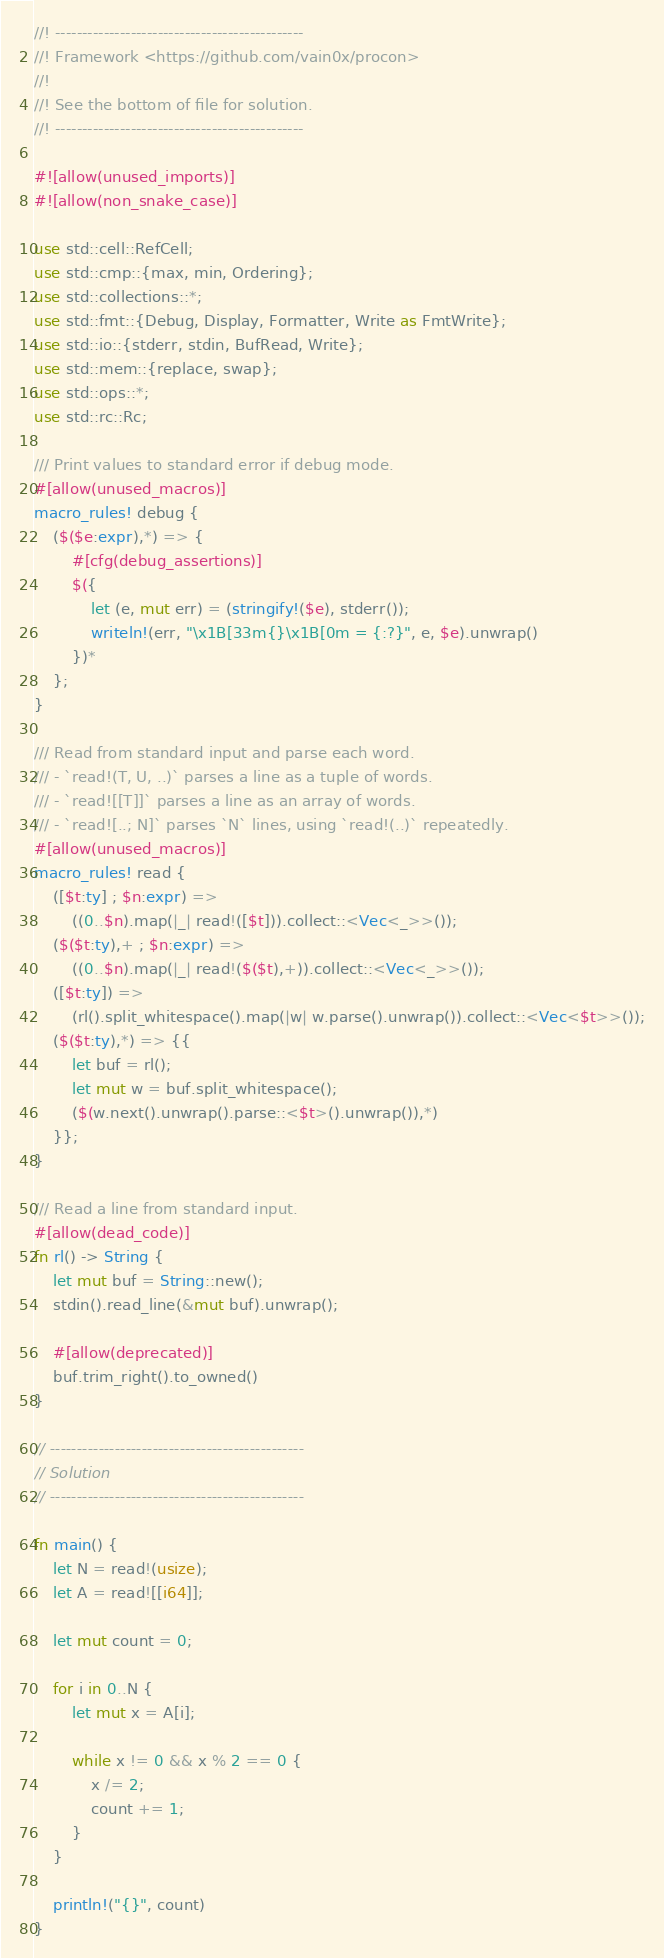<code> <loc_0><loc_0><loc_500><loc_500><_Rust_>//! ----------------------------------------------
//! Framework <https://github.com/vain0x/procon>
//!
//! See the bottom of file for solution.
//! ----------------------------------------------

#![allow(unused_imports)]
#![allow(non_snake_case)]

use std::cell::RefCell;
use std::cmp::{max, min, Ordering};
use std::collections::*;
use std::fmt::{Debug, Display, Formatter, Write as FmtWrite};
use std::io::{stderr, stdin, BufRead, Write};
use std::mem::{replace, swap};
use std::ops::*;
use std::rc::Rc;

/// Print values to standard error if debug mode.
#[allow(unused_macros)]
macro_rules! debug {
    ($($e:expr),*) => {
        #[cfg(debug_assertions)]
        $({
            let (e, mut err) = (stringify!($e), stderr());
            writeln!(err, "\x1B[33m{}\x1B[0m = {:?}", e, $e).unwrap()
        })*
    };
}

/// Read from standard input and parse each word.
/// - `read!(T, U, ..)` parses a line as a tuple of words.
/// - `read![[T]]` parses a line as an array of words.
/// - `read![..; N]` parses `N` lines, using `read!(..)` repeatedly.
#[allow(unused_macros)]
macro_rules! read {
    ([$t:ty] ; $n:expr) =>
        ((0..$n).map(|_| read!([$t])).collect::<Vec<_>>());
    ($($t:ty),+ ; $n:expr) =>
        ((0..$n).map(|_| read!($($t),+)).collect::<Vec<_>>());
    ([$t:ty]) =>
        (rl().split_whitespace().map(|w| w.parse().unwrap()).collect::<Vec<$t>>());
    ($($t:ty),*) => {{
        let buf = rl();
        let mut w = buf.split_whitespace();
        ($(w.next().unwrap().parse::<$t>().unwrap()),*)
    }};
}

/// Read a line from standard input.
#[allow(dead_code)]
fn rl() -> String {
    let mut buf = String::new();
    stdin().read_line(&mut buf).unwrap();

    #[allow(deprecated)]
    buf.trim_right().to_owned()
}

// -----------------------------------------------
// Solution
// -----------------------------------------------

fn main() {
    let N = read!(usize);
    let A = read![[i64]];

    let mut count = 0;

    for i in 0..N {
        let mut x = A[i];

        while x != 0 && x % 2 == 0 {
            x /= 2;
            count += 1;
        }
    }

    println!("{}", count)
}
</code> 